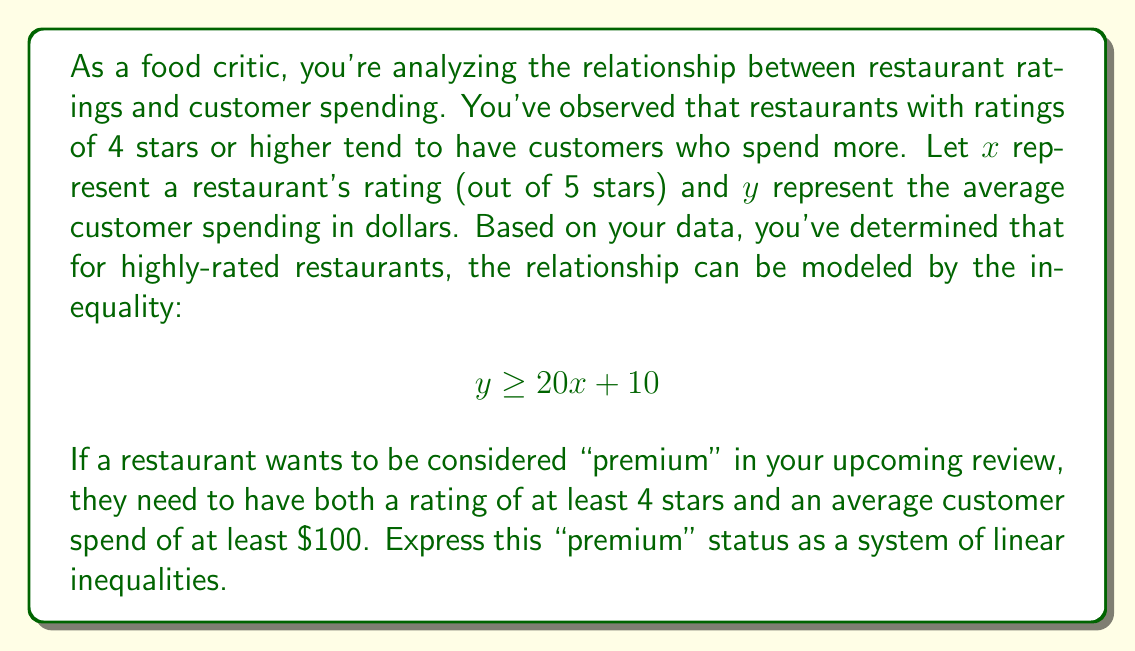Help me with this question. To solve this problem, we need to express both conditions as inequalities:

1. The rating should be at least 4 stars:
   $$x \geq 4$$

2. The average customer spend should be at least $100:
   $$y \geq 100$$

3. We also need to include the given inequality that relates rating to spending:
   $$y \geq 20x + 10$$

Therefore, the system of linear inequalities that defines a "premium" restaurant is:

$$\begin{cases}
x \geq 4 \\
y \geq 100 \\
y \geq 20x + 10
\end{cases}$$

This system of inequalities ensures that:
- The restaurant has a rating of at least 4 stars
- The average customer spend is at least $100
- The relationship between rating and spending follows the observed trend for highly-rated restaurants

[asy]
size(200,200);
import graph;

// Draw axes
axes("x","y",Arrow);

// Draw inequalities
draw((0,100)--(5,100),blue);
draw((4,0)--(4,200),blue);
draw((0,10)--(5,110),red);

// Shade the feasible region
fill((4,100)--(5,100)--(5,110)--(4,90)--cycle,paleblue);

// Label the region
label("Premium Region", (4.5,105), E);

// Label axes
label("Rating (x)", (5,0), S);
label("Avg. Spend (y)", (0,200), W);

// Add legend
label("x ≥ 4", (0.5,180), E, blue);
label("y ≥ 100", (0.5,170), E, blue);
label("y ≥ 20x + 10", (0.5,160), E, red);
[/asy]

The shaded region in the graph represents the "premium" restaurants that satisfy all three inequalities.
Answer: The system of linear inequalities representing "premium" restaurant status is:

$$\begin{cases}
x \geq 4 \\
y \geq 100 \\
y \geq 20x + 10
\end{cases}$$

Where $x$ is the restaurant's rating (out of 5 stars) and $y$ is the average customer spending in dollars. 